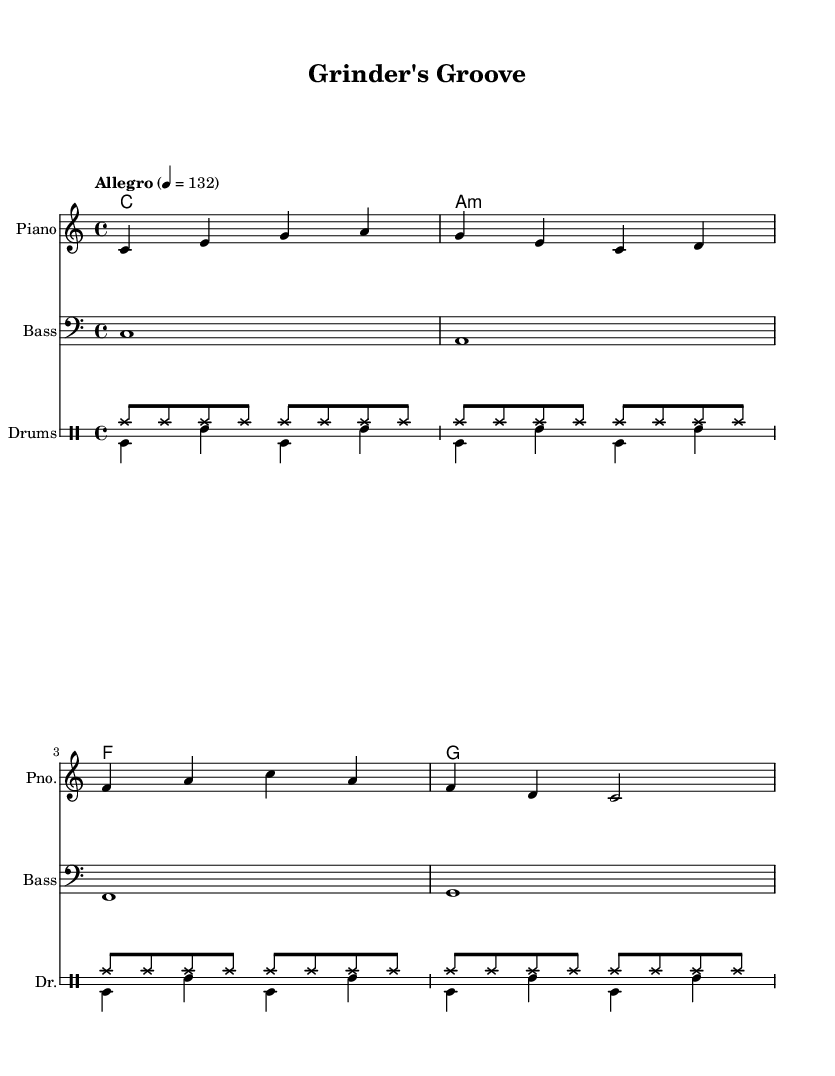What is the key signature of this music? The key signature is C major, which has no sharps or flats.
Answer: C major What is the time signature of this music? The time signature indicated in the sheet music is 4/4, showing that each measure has four beats.
Answer: 4/4 What is the tempo marking for this piece? The tempo marking "Allegro" is indicated with an eighth note = 132, suggesting a fast-paced performance.
Answer: Allegro How many measures are in the melody section? Counting the bars in the melody part reveals there are four measures in total.
Answer: 4 What chord is played in the first measure of the harmonies? The first measure in the harmonies section shows a C major chord being played.
Answer: C What type of instrumental ensemble does this music include? The score consists of a piano, bass, and drum set, forming a small ensemble suitable for upbeat pop songs.
Answer: Piano, Bass, Drums What is the last bass note in the score? The last note in the bass section is a G note, which concludes the piece.
Answer: G 